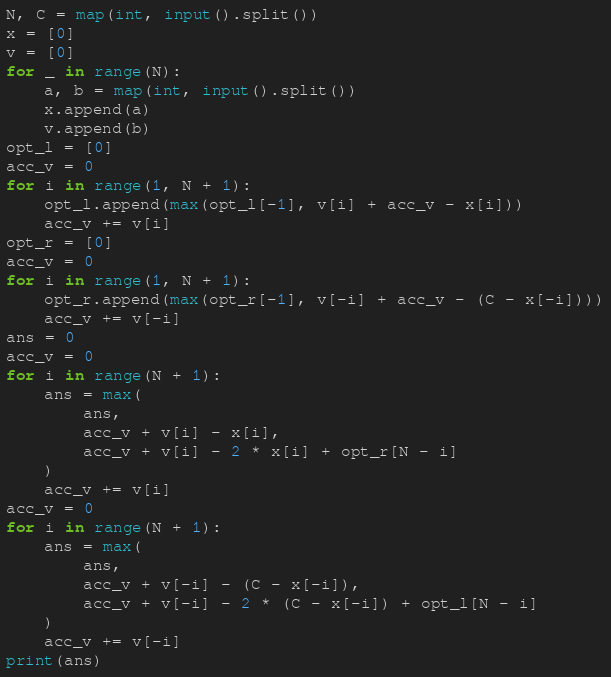<code> <loc_0><loc_0><loc_500><loc_500><_Python_>N, C = map(int, input().split())
x = [0]
v = [0]
for _ in range(N):
    a, b = map(int, input().split())
    x.append(a)
    v.append(b)
opt_l = [0]
acc_v = 0
for i in range(1, N + 1):
    opt_l.append(max(opt_l[-1], v[i] + acc_v - x[i]))
    acc_v += v[i]
opt_r = [0]
acc_v = 0
for i in range(1, N + 1):
    opt_r.append(max(opt_r[-1], v[-i] + acc_v - (C - x[-i])))
    acc_v += v[-i]
ans = 0
acc_v = 0
for i in range(N + 1):
    ans = max(
        ans,
        acc_v + v[i] - x[i],
        acc_v + v[i] - 2 * x[i] + opt_r[N - i]
    )
    acc_v += v[i]
acc_v = 0
for i in range(N + 1):
    ans = max(
        ans,
        acc_v + v[-i] - (C - x[-i]),
        acc_v + v[-i] - 2 * (C - x[-i]) + opt_l[N - i]
    )
    acc_v += v[-i]
print(ans)</code> 